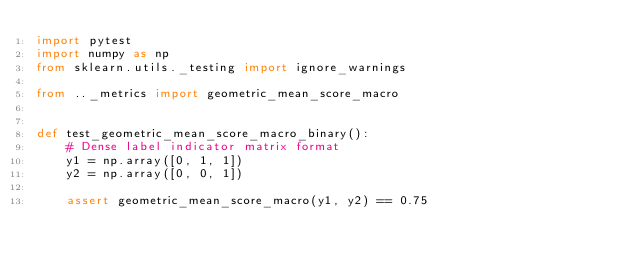Convert code to text. <code><loc_0><loc_0><loc_500><loc_500><_Python_>import pytest
import numpy as np
from sklearn.utils._testing import ignore_warnings

from .._metrics import geometric_mean_score_macro


def test_geometric_mean_score_macro_binary():
    # Dense label indicator matrix format
    y1 = np.array([0, 1, 1])
    y2 = np.array([0, 0, 1])

    assert geometric_mean_score_macro(y1, y2) == 0.75</code> 